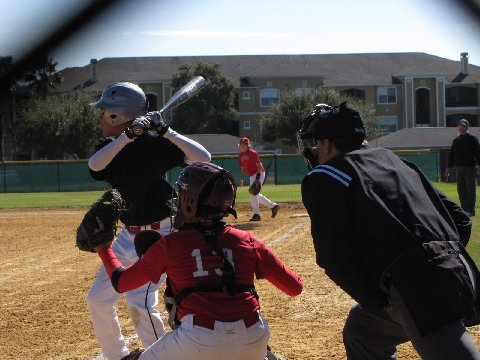Please extract the text content from this image. 13 